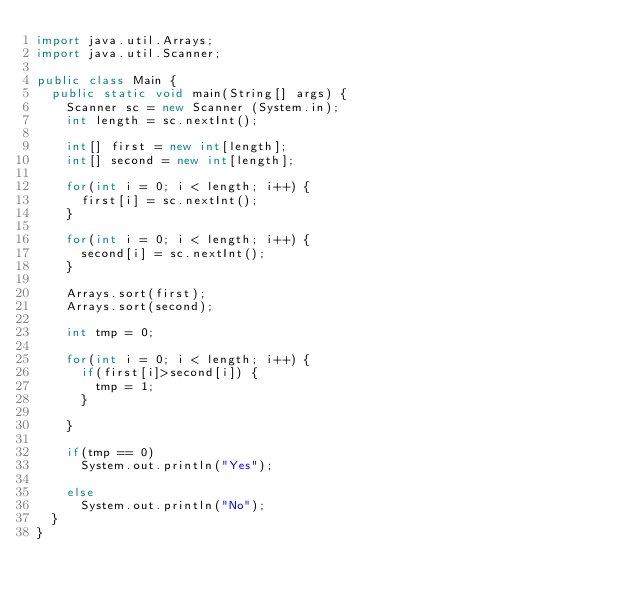Convert code to text. <code><loc_0><loc_0><loc_500><loc_500><_Java_>import java.util.Arrays;
import java.util.Scanner;

public class Main {
	public static void main(String[] args) {
		Scanner sc = new Scanner (System.in);
		int length = sc.nextInt();
		
		int[] first = new int[length];
		int[] second = new int[length];
		
		for(int i = 0; i < length; i++) {
			first[i] = sc.nextInt();
		}
		
		for(int i = 0; i < length; i++) {
			second[i] = sc.nextInt();
		}
		
		Arrays.sort(first);
		Arrays.sort(second);
		
		int tmp = 0;
		
		for(int i = 0; i < length; i++) {
			if(first[i]>second[i]) {
				tmp = 1;
			}
			
		}
		
		if(tmp == 0) 
			System.out.println("Yes");
		
		else
			System.out.println("No");
	}
}</code> 